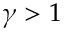<formula> <loc_0><loc_0><loc_500><loc_500>\gamma > 1</formula> 